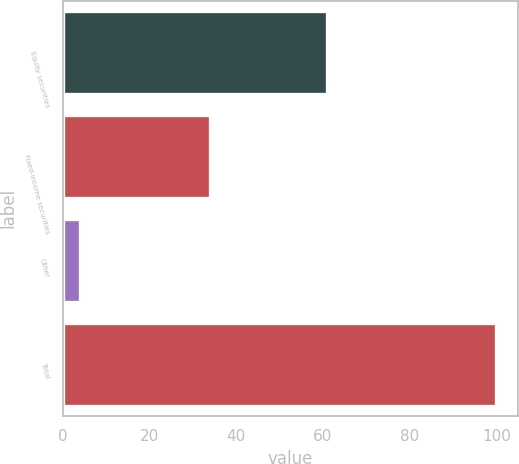Convert chart. <chart><loc_0><loc_0><loc_500><loc_500><bar_chart><fcel>Equity securities<fcel>Fixed-income securities<fcel>Other<fcel>Total<nl><fcel>61<fcel>34<fcel>4<fcel>100<nl></chart> 